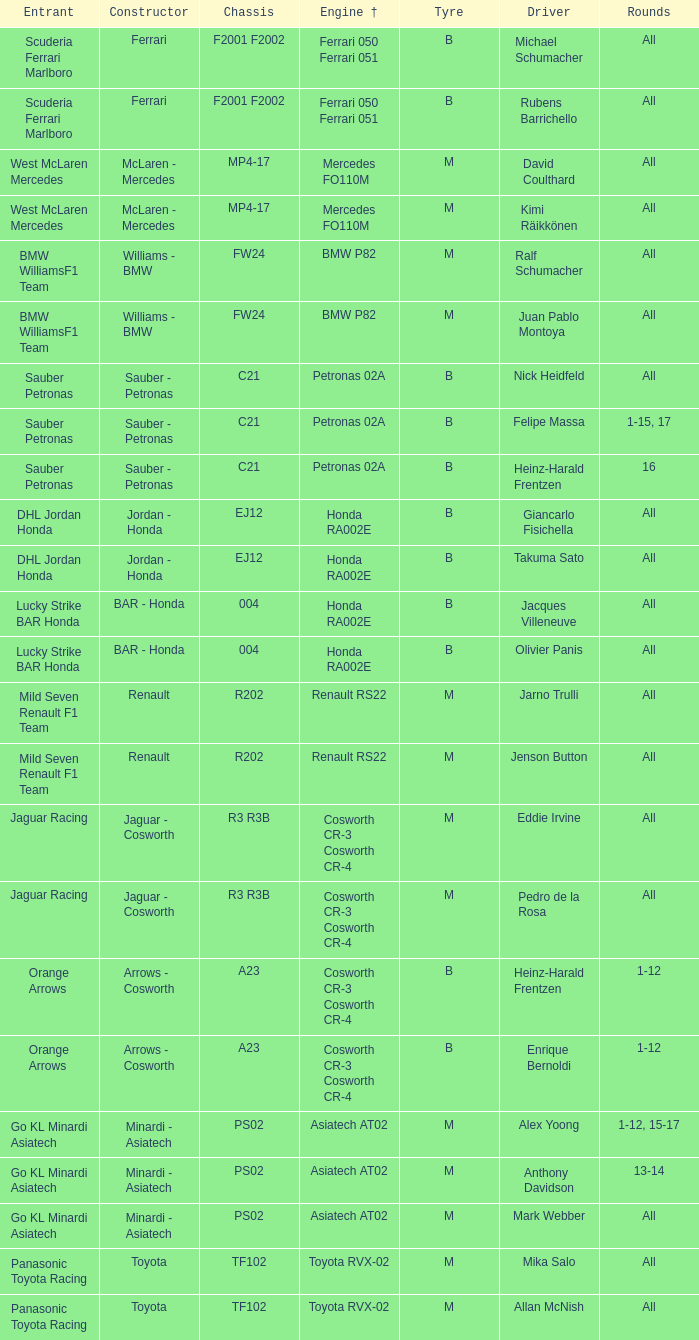Who is the contender when the engine is bmw p82? BMW WilliamsF1 Team, BMW WilliamsF1 Team. 